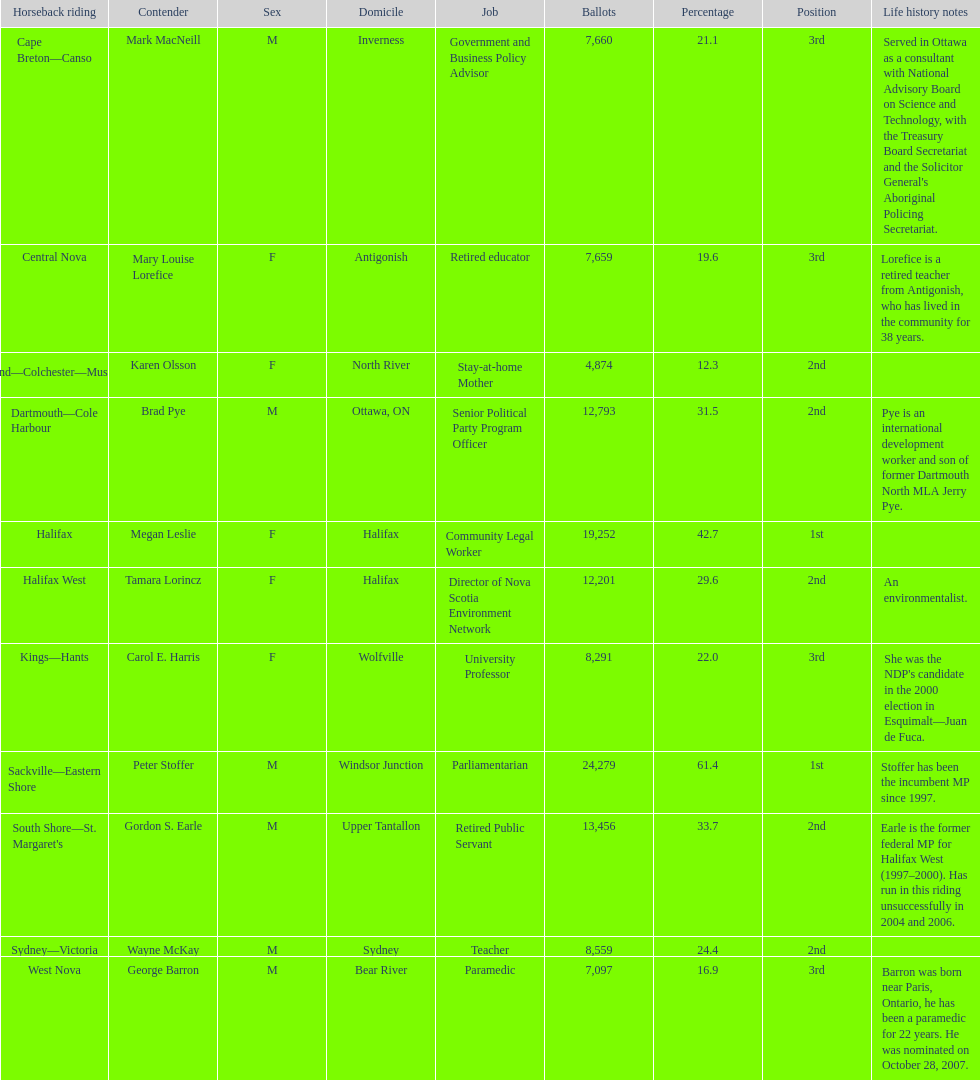How many candidates had more votes than tamara lorincz? 4. 